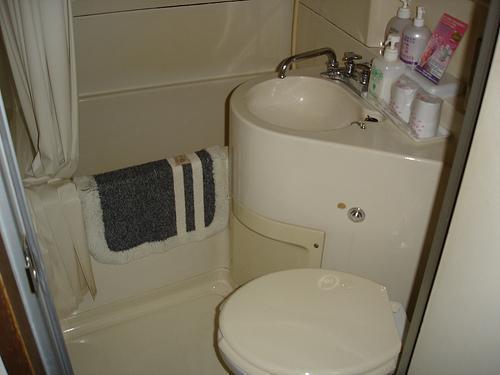How many toilets are in the bathroom?
Give a very brief answer. 1. How many sinks are in the picture?
Give a very brief answer. 1. 